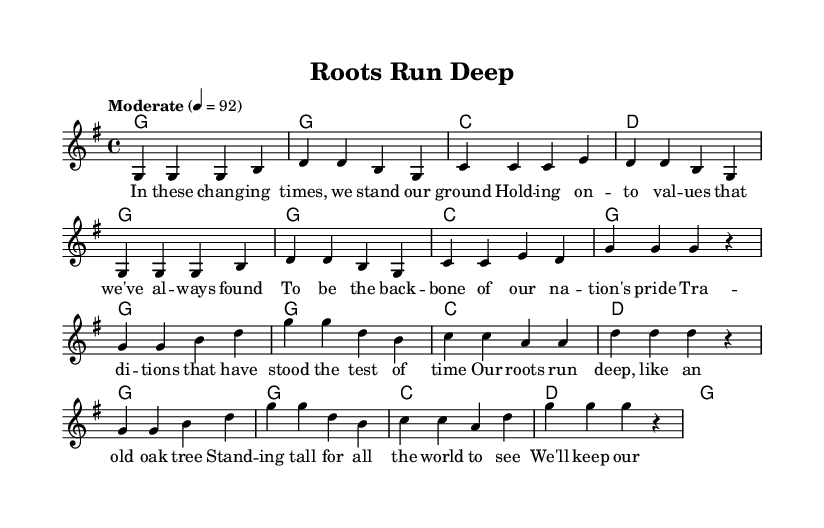What is the key signature of this music? The key signature indicated is G major, which has one sharp (F#). This can be seen in the key signature notation at the beginning of the sheet music.
Answer: G major What is the time signature of this piece? The time signature is 4/4, which means there are four beats in each measure and a quarter note gets one beat. This can be identified by the notation at the beginning of the sheet music.
Answer: 4/4 What is the tempo marking for this piece? The tempo marking is "Moderate" with a metronome value of 92 beats per minute. This is indicated in the tempo marking section of the score.
Answer: Moderate 4 = 92 How many measures are in the verse? The verse contains eight measures, as counted from the melody section under the verse part. Each time a bar line is encountered, it indicates the end of a measure.
Answer: Eight What is the primary theme of this song? The primary theme revolves around preserving traditional values and heritage, as noted in the lyrics, which express commitment to these ideals.
Answer: Preserving traditions How does the chorus differ musically from the verse? The chorus uses a slightly different melodic structure and focuses on the theme of roots and heritage, while the verse emphasizes standing firm in traditional values. This can be inferred from the distinct melodic lines and lyrics provided for each part.
Answer: Melodic structure and theme What type of musical form is being used in this piece? The piece uses a verse-chorus form, alternating between verses and the chorus, which is a typical structure found in country music. This is evident from the naming of sections and their respective lyrics.
Answer: Verse-chorus 